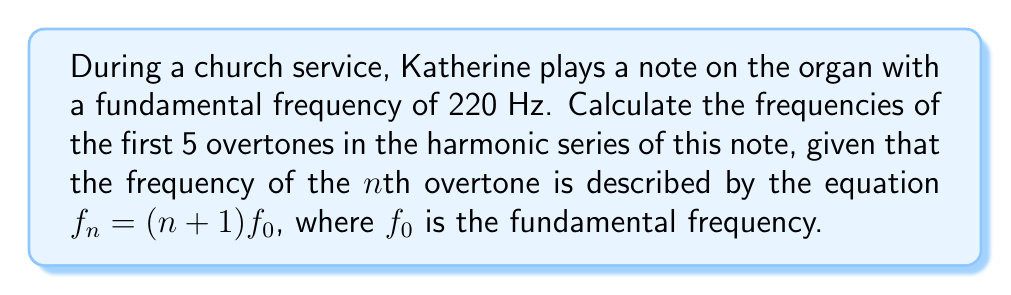What is the answer to this math problem? To find the frequencies of the first 5 overtones, we'll use the given equation $f_n = (n+1)f_0$, where $f_0 = 220$ Hz.

1. First overtone (n = 1):
   $f_1 = (1+1) \cdot 220 = 2 \cdot 220 = 440$ Hz

2. Second overtone (n = 2):
   $f_2 = (2+1) \cdot 220 = 3 \cdot 220 = 660$ Hz

3. Third overtone (n = 3):
   $f_3 = (3+1) \cdot 220 = 4 \cdot 220 = 880$ Hz

4. Fourth overtone (n = 4):
   $f_4 = (4+1) \cdot 220 = 5 \cdot 220 = 1100$ Hz

5. Fifth overtone (n = 5):
   $f_5 = (5+1) \cdot 220 = 6 \cdot 220 = 1320$ Hz

The frequencies of the first 5 overtones form an arithmetic sequence with a common difference of 220 Hz, which is the fundamental frequency.
Answer: 440 Hz, 660 Hz, 880 Hz, 1100 Hz, 1320 Hz 